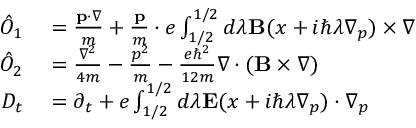<formula> <loc_0><loc_0><loc_500><loc_500>\begin{array} { r l } { \hat { O } _ { 1 } } & = \frac { p \cdot \nabla } { m } + \frac { p } { m } \cdot e \int _ { 1 / 2 } ^ { 1 / 2 } d \lambda B ( x + i \hbar { \lambda } \nabla _ { p } ) \times \nabla } \\ { \hat { O } _ { 2 } } & = \frac { \nabla ^ { 2 } } { 4 m } - \frac { p ^ { 2 } } { m } - \frac { e \hbar { ^ } { 2 } } { 1 2 m } \nabla \cdot ( B \times \nabla ) } \\ { D _ { t } } & = \partial _ { t } + e \int _ { 1 / 2 } ^ { 1 / 2 } d \lambda E ( x + i \hbar { \lambda } \nabla _ { p } ) \cdot \nabla _ { p } } \end{array}</formula> 